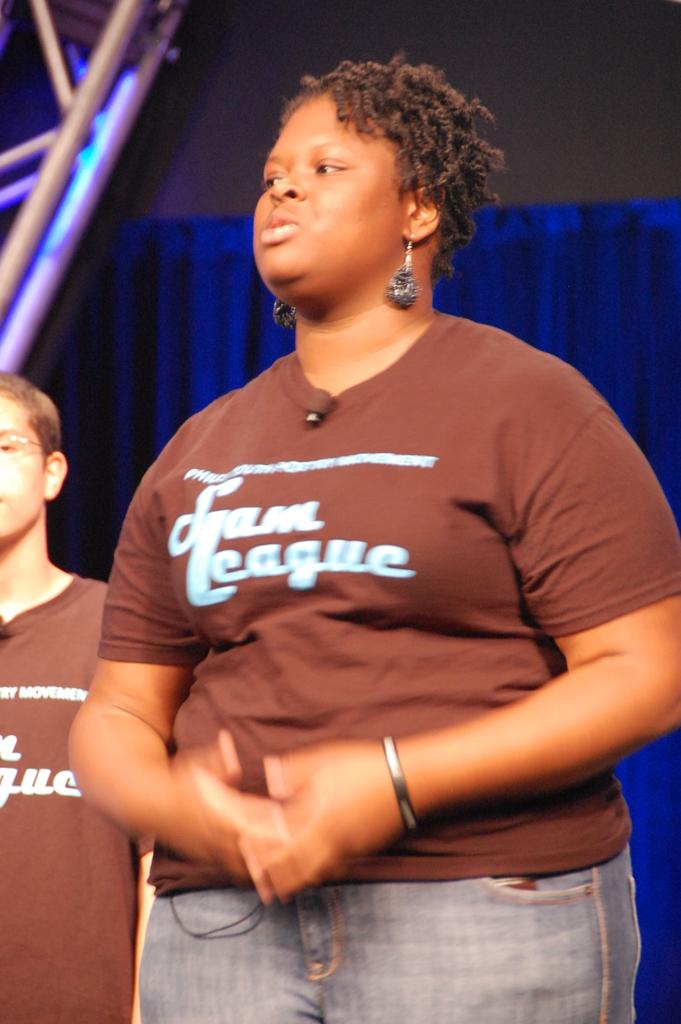<image>
Provide a brief description of the given image. The bottom word on both of the brown shirts is League. 